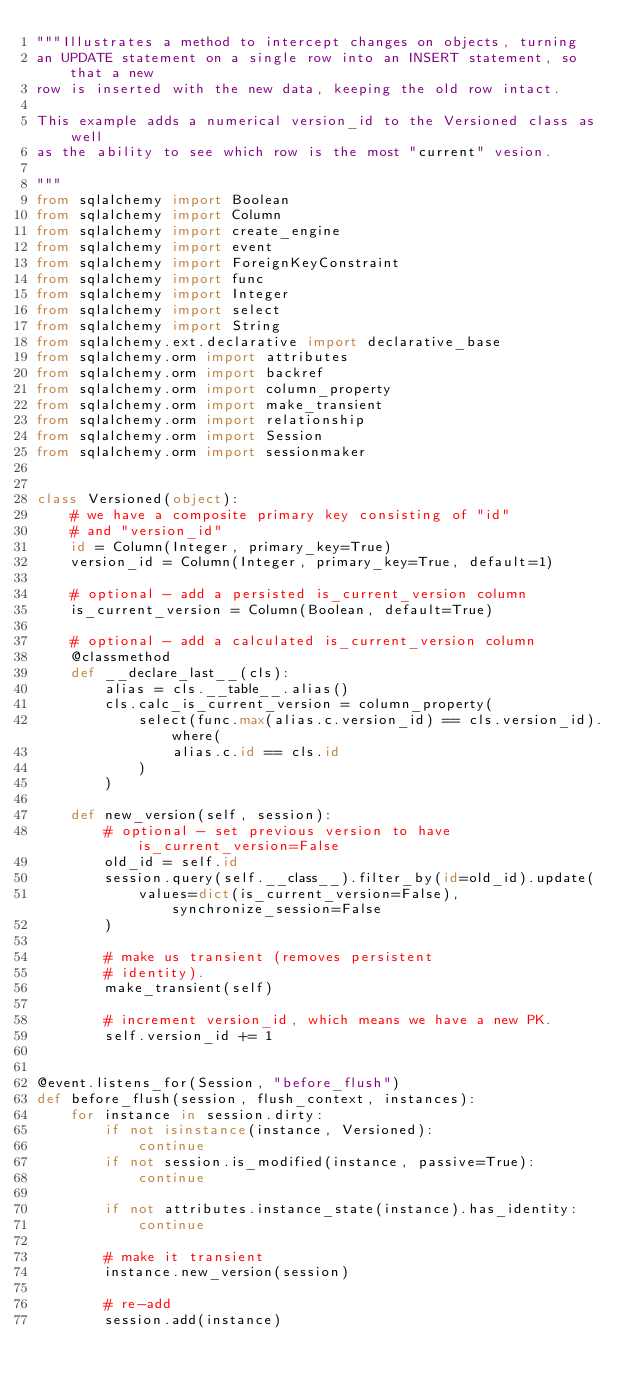<code> <loc_0><loc_0><loc_500><loc_500><_Python_>"""Illustrates a method to intercept changes on objects, turning
an UPDATE statement on a single row into an INSERT statement, so that a new
row is inserted with the new data, keeping the old row intact.

This example adds a numerical version_id to the Versioned class as well
as the ability to see which row is the most "current" vesion.

"""
from sqlalchemy import Boolean
from sqlalchemy import Column
from sqlalchemy import create_engine
from sqlalchemy import event
from sqlalchemy import ForeignKeyConstraint
from sqlalchemy import func
from sqlalchemy import Integer
from sqlalchemy import select
from sqlalchemy import String
from sqlalchemy.ext.declarative import declarative_base
from sqlalchemy.orm import attributes
from sqlalchemy.orm import backref
from sqlalchemy.orm import column_property
from sqlalchemy.orm import make_transient
from sqlalchemy.orm import relationship
from sqlalchemy.orm import Session
from sqlalchemy.orm import sessionmaker


class Versioned(object):
    # we have a composite primary key consisting of "id"
    # and "version_id"
    id = Column(Integer, primary_key=True)
    version_id = Column(Integer, primary_key=True, default=1)

    # optional - add a persisted is_current_version column
    is_current_version = Column(Boolean, default=True)

    # optional - add a calculated is_current_version column
    @classmethod
    def __declare_last__(cls):
        alias = cls.__table__.alias()
        cls.calc_is_current_version = column_property(
            select(func.max(alias.c.version_id) == cls.version_id).where(
                alias.c.id == cls.id
            )
        )

    def new_version(self, session):
        # optional - set previous version to have is_current_version=False
        old_id = self.id
        session.query(self.__class__).filter_by(id=old_id).update(
            values=dict(is_current_version=False), synchronize_session=False
        )

        # make us transient (removes persistent
        # identity).
        make_transient(self)

        # increment version_id, which means we have a new PK.
        self.version_id += 1


@event.listens_for(Session, "before_flush")
def before_flush(session, flush_context, instances):
    for instance in session.dirty:
        if not isinstance(instance, Versioned):
            continue
        if not session.is_modified(instance, passive=True):
            continue

        if not attributes.instance_state(instance).has_identity:
            continue

        # make it transient
        instance.new_version(session)

        # re-add
        session.add(instance)

</code> 